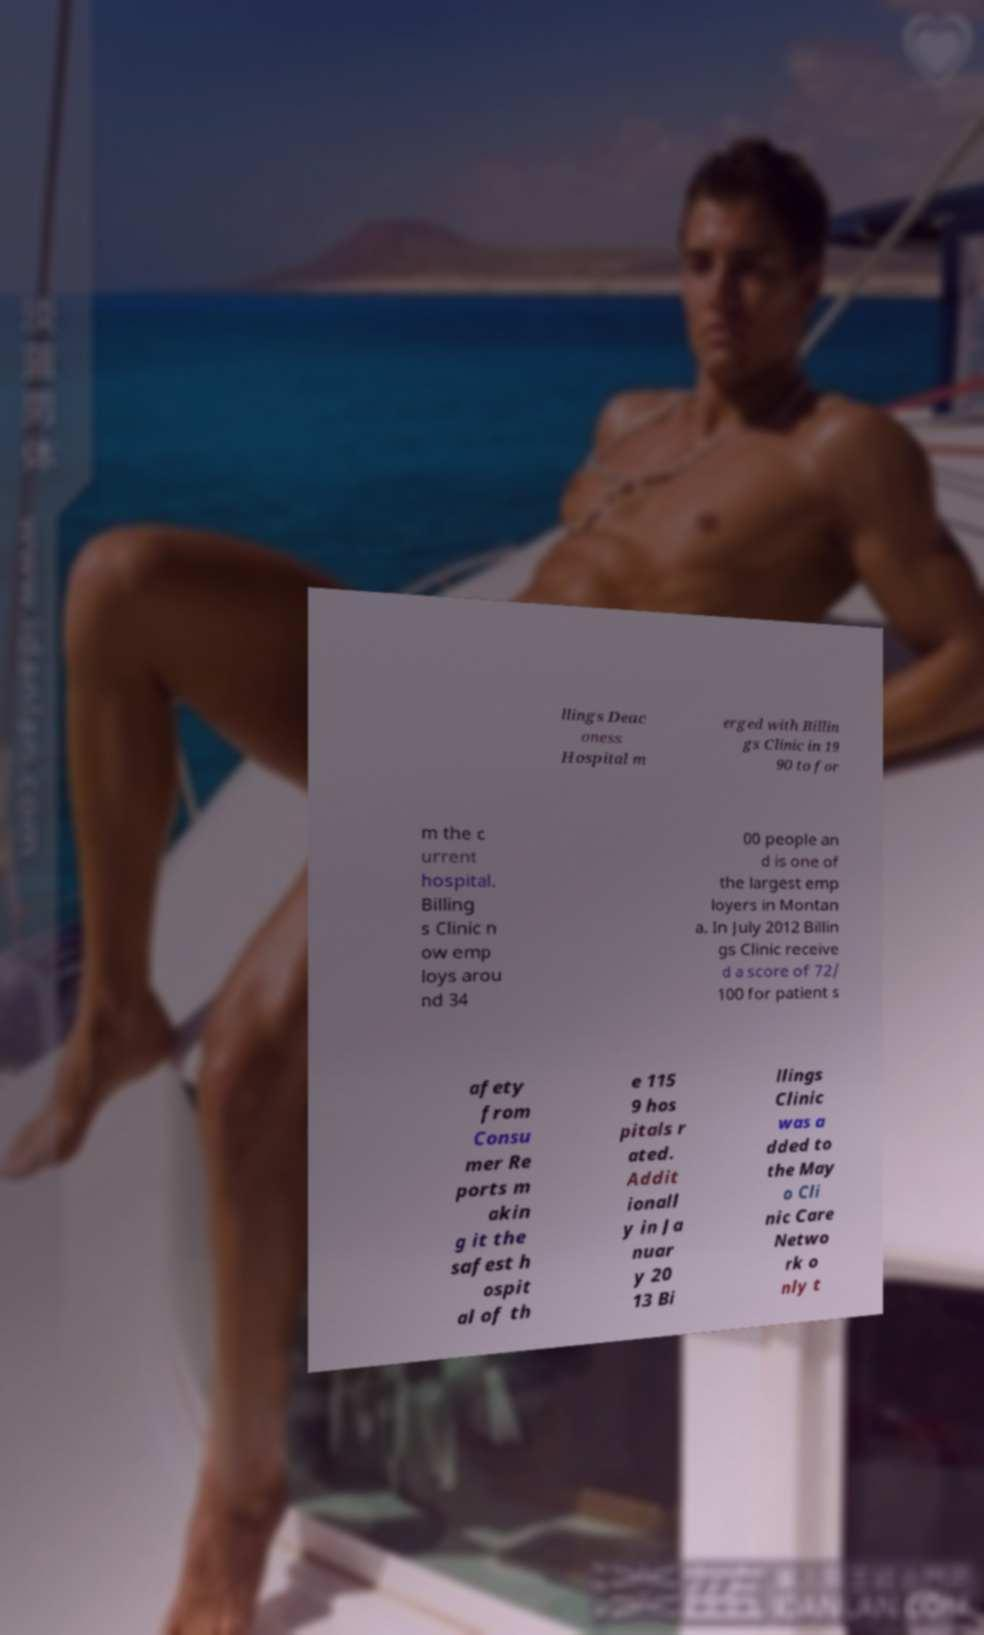Can you accurately transcribe the text from the provided image for me? llings Deac oness Hospital m erged with Billin gs Clinic in 19 90 to for m the c urrent hospital. Billing s Clinic n ow emp loys arou nd 34 00 people an d is one of the largest emp loyers in Montan a. In July 2012 Billin gs Clinic receive d a score of 72/ 100 for patient s afety from Consu mer Re ports m akin g it the safest h ospit al of th e 115 9 hos pitals r ated. Addit ionall y in Ja nuar y 20 13 Bi llings Clinic was a dded to the May o Cli nic Care Netwo rk o nly t 